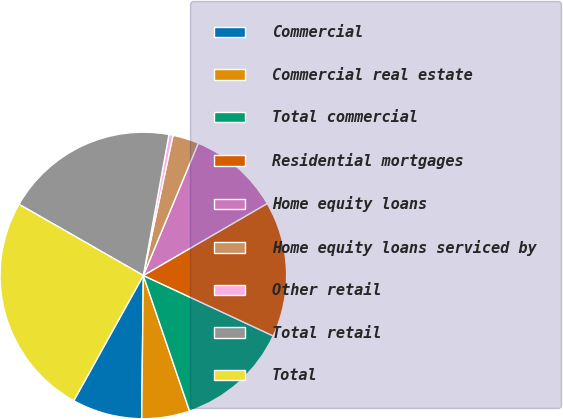Convert chart. <chart><loc_0><loc_0><loc_500><loc_500><pie_chart><fcel>Commercial<fcel>Commercial real estate<fcel>Total commercial<fcel>Residential mortgages<fcel>Home equity loans<fcel>Home equity loans serviced by<fcel>Other retail<fcel>Total retail<fcel>Total<nl><fcel>7.89%<fcel>5.41%<fcel>12.84%<fcel>15.31%<fcel>10.36%<fcel>2.94%<fcel>0.46%<fcel>19.59%<fcel>25.21%<nl></chart> 